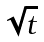<formula> <loc_0><loc_0><loc_500><loc_500>\sqrt { t }</formula> 